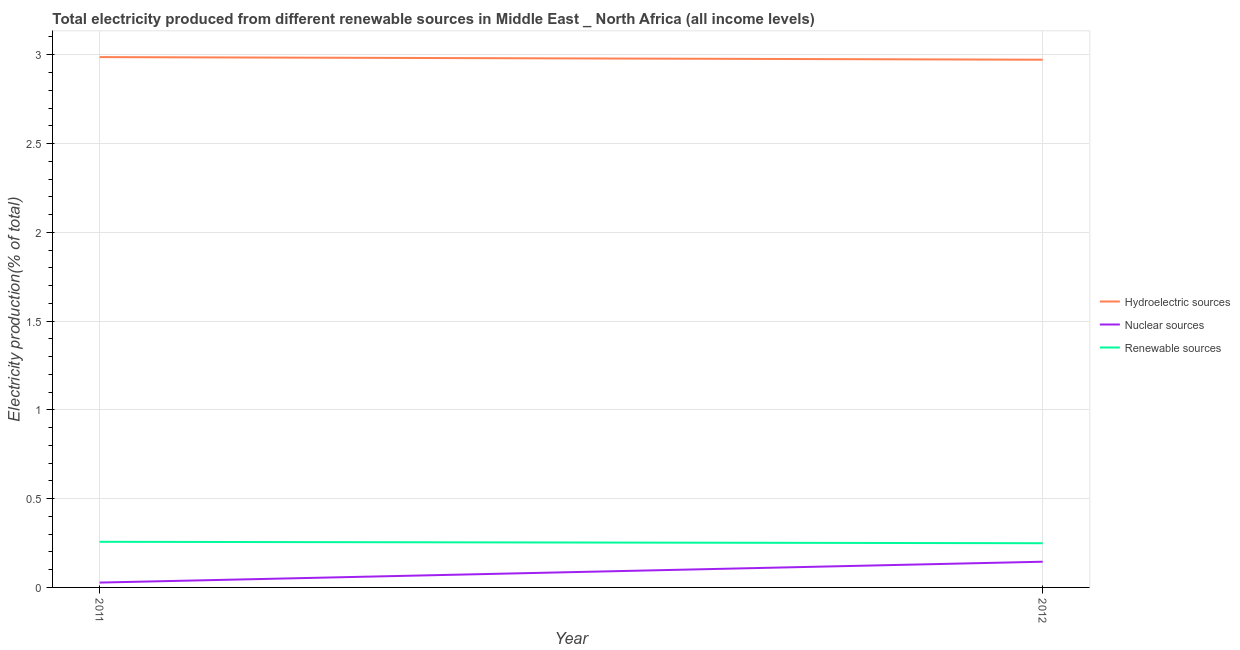How many different coloured lines are there?
Your answer should be compact. 3. What is the percentage of electricity produced by renewable sources in 2011?
Ensure brevity in your answer.  0.26. Across all years, what is the maximum percentage of electricity produced by nuclear sources?
Your response must be concise. 0.14. Across all years, what is the minimum percentage of electricity produced by nuclear sources?
Your answer should be very brief. 0.03. What is the total percentage of electricity produced by nuclear sources in the graph?
Your answer should be compact. 0.17. What is the difference between the percentage of electricity produced by nuclear sources in 2011 and that in 2012?
Your answer should be very brief. -0.12. What is the difference between the percentage of electricity produced by renewable sources in 2012 and the percentage of electricity produced by hydroelectric sources in 2011?
Your answer should be very brief. -2.74. What is the average percentage of electricity produced by renewable sources per year?
Offer a terse response. 0.25. In the year 2012, what is the difference between the percentage of electricity produced by hydroelectric sources and percentage of electricity produced by nuclear sources?
Ensure brevity in your answer.  2.83. What is the ratio of the percentage of electricity produced by nuclear sources in 2011 to that in 2012?
Offer a very short reply. 0.19. In how many years, is the percentage of electricity produced by hydroelectric sources greater than the average percentage of electricity produced by hydroelectric sources taken over all years?
Provide a succinct answer. 1. Does the percentage of electricity produced by nuclear sources monotonically increase over the years?
Your answer should be compact. Yes. Is the percentage of electricity produced by hydroelectric sources strictly less than the percentage of electricity produced by nuclear sources over the years?
Keep it short and to the point. No. How many lines are there?
Your answer should be compact. 3. What is the difference between two consecutive major ticks on the Y-axis?
Keep it short and to the point. 0.5. Does the graph contain grids?
Your response must be concise. Yes. Where does the legend appear in the graph?
Keep it short and to the point. Center right. How many legend labels are there?
Provide a short and direct response. 3. How are the legend labels stacked?
Provide a succinct answer. Vertical. What is the title of the graph?
Ensure brevity in your answer.  Total electricity produced from different renewable sources in Middle East _ North Africa (all income levels). What is the label or title of the Y-axis?
Make the answer very short. Electricity production(% of total). What is the Electricity production(% of total) of Hydroelectric sources in 2011?
Your response must be concise. 2.99. What is the Electricity production(% of total) of Nuclear sources in 2011?
Give a very brief answer. 0.03. What is the Electricity production(% of total) in Renewable sources in 2011?
Offer a very short reply. 0.26. What is the Electricity production(% of total) of Hydroelectric sources in 2012?
Your answer should be compact. 2.97. What is the Electricity production(% of total) in Nuclear sources in 2012?
Give a very brief answer. 0.14. What is the Electricity production(% of total) in Renewable sources in 2012?
Offer a very short reply. 0.25. Across all years, what is the maximum Electricity production(% of total) of Hydroelectric sources?
Your answer should be compact. 2.99. Across all years, what is the maximum Electricity production(% of total) of Nuclear sources?
Offer a very short reply. 0.14. Across all years, what is the maximum Electricity production(% of total) in Renewable sources?
Your answer should be compact. 0.26. Across all years, what is the minimum Electricity production(% of total) of Hydroelectric sources?
Your answer should be compact. 2.97. Across all years, what is the minimum Electricity production(% of total) of Nuclear sources?
Provide a succinct answer. 0.03. Across all years, what is the minimum Electricity production(% of total) in Renewable sources?
Offer a very short reply. 0.25. What is the total Electricity production(% of total) of Hydroelectric sources in the graph?
Offer a terse response. 5.96. What is the total Electricity production(% of total) of Nuclear sources in the graph?
Your answer should be compact. 0.17. What is the total Electricity production(% of total) of Renewable sources in the graph?
Ensure brevity in your answer.  0.51. What is the difference between the Electricity production(% of total) of Hydroelectric sources in 2011 and that in 2012?
Offer a very short reply. 0.01. What is the difference between the Electricity production(% of total) of Nuclear sources in 2011 and that in 2012?
Provide a succinct answer. -0.12. What is the difference between the Electricity production(% of total) in Renewable sources in 2011 and that in 2012?
Offer a very short reply. 0.01. What is the difference between the Electricity production(% of total) of Hydroelectric sources in 2011 and the Electricity production(% of total) of Nuclear sources in 2012?
Keep it short and to the point. 2.84. What is the difference between the Electricity production(% of total) in Hydroelectric sources in 2011 and the Electricity production(% of total) in Renewable sources in 2012?
Ensure brevity in your answer.  2.74. What is the difference between the Electricity production(% of total) in Nuclear sources in 2011 and the Electricity production(% of total) in Renewable sources in 2012?
Provide a succinct answer. -0.22. What is the average Electricity production(% of total) of Hydroelectric sources per year?
Provide a succinct answer. 2.98. What is the average Electricity production(% of total) of Nuclear sources per year?
Give a very brief answer. 0.09. What is the average Electricity production(% of total) in Renewable sources per year?
Make the answer very short. 0.25. In the year 2011, what is the difference between the Electricity production(% of total) of Hydroelectric sources and Electricity production(% of total) of Nuclear sources?
Give a very brief answer. 2.96. In the year 2011, what is the difference between the Electricity production(% of total) of Hydroelectric sources and Electricity production(% of total) of Renewable sources?
Your answer should be compact. 2.73. In the year 2011, what is the difference between the Electricity production(% of total) in Nuclear sources and Electricity production(% of total) in Renewable sources?
Your response must be concise. -0.23. In the year 2012, what is the difference between the Electricity production(% of total) of Hydroelectric sources and Electricity production(% of total) of Nuclear sources?
Your answer should be very brief. 2.83. In the year 2012, what is the difference between the Electricity production(% of total) in Hydroelectric sources and Electricity production(% of total) in Renewable sources?
Make the answer very short. 2.72. In the year 2012, what is the difference between the Electricity production(% of total) of Nuclear sources and Electricity production(% of total) of Renewable sources?
Provide a succinct answer. -0.1. What is the ratio of the Electricity production(% of total) of Hydroelectric sources in 2011 to that in 2012?
Give a very brief answer. 1. What is the ratio of the Electricity production(% of total) of Nuclear sources in 2011 to that in 2012?
Offer a very short reply. 0.19. What is the ratio of the Electricity production(% of total) in Renewable sources in 2011 to that in 2012?
Your answer should be compact. 1.03. What is the difference between the highest and the second highest Electricity production(% of total) in Hydroelectric sources?
Give a very brief answer. 0.01. What is the difference between the highest and the second highest Electricity production(% of total) in Nuclear sources?
Make the answer very short. 0.12. What is the difference between the highest and the second highest Electricity production(% of total) of Renewable sources?
Keep it short and to the point. 0.01. What is the difference between the highest and the lowest Electricity production(% of total) of Hydroelectric sources?
Keep it short and to the point. 0.01. What is the difference between the highest and the lowest Electricity production(% of total) in Nuclear sources?
Ensure brevity in your answer.  0.12. What is the difference between the highest and the lowest Electricity production(% of total) of Renewable sources?
Offer a terse response. 0.01. 